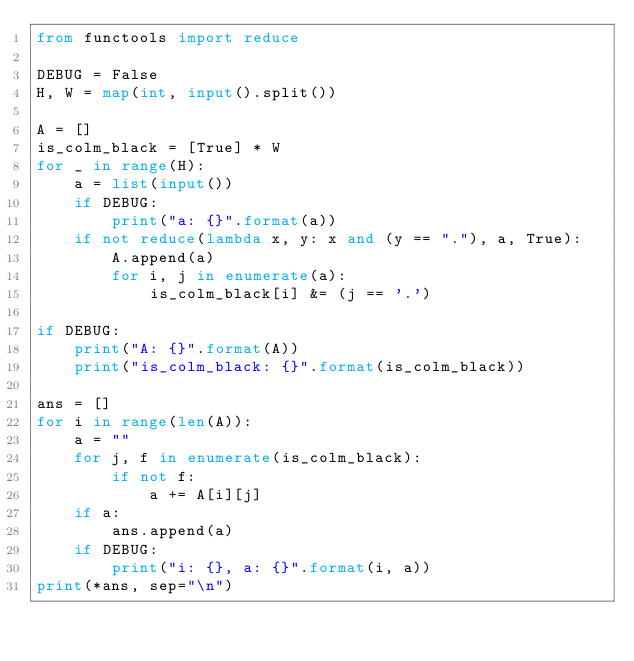Convert code to text. <code><loc_0><loc_0><loc_500><loc_500><_Python_>from functools import reduce

DEBUG = False
H, W = map(int, input().split())

A = []
is_colm_black = [True] * W
for _ in range(H):
    a = list(input())
    if DEBUG:
        print("a: {}".format(a))
    if not reduce(lambda x, y: x and (y == "."), a, True):
        A.append(a)
        for i, j in enumerate(a):
            is_colm_black[i] &= (j == '.')

if DEBUG:
    print("A: {}".format(A))
    print("is_colm_black: {}".format(is_colm_black))

ans = []
for i in range(len(A)):
    a = ""
    for j, f in enumerate(is_colm_black):
        if not f:
            a += A[i][j]
    if a:
        ans.append(a)
    if DEBUG:
        print("i: {}, a: {}".format(i, a))
print(*ans, sep="\n")
</code> 